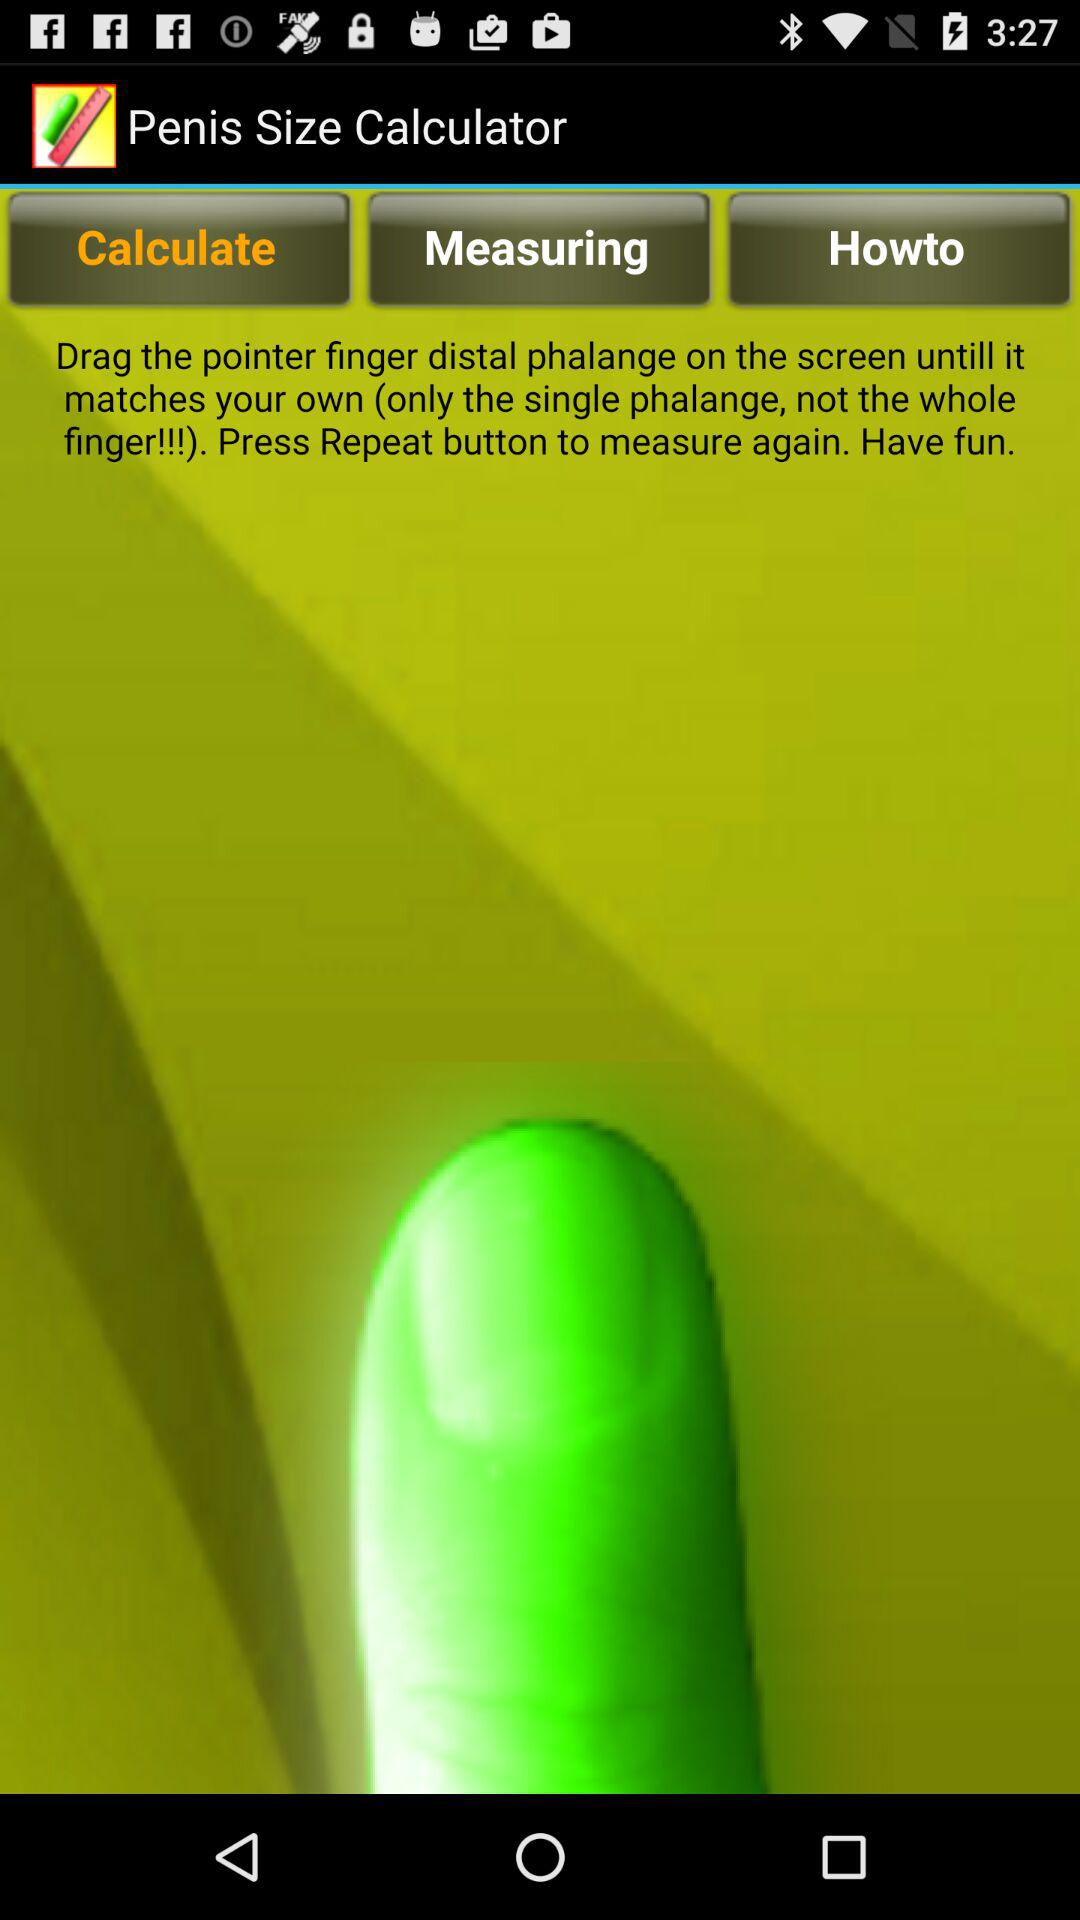Which tab is selected? The selected tab is "Calculate". 